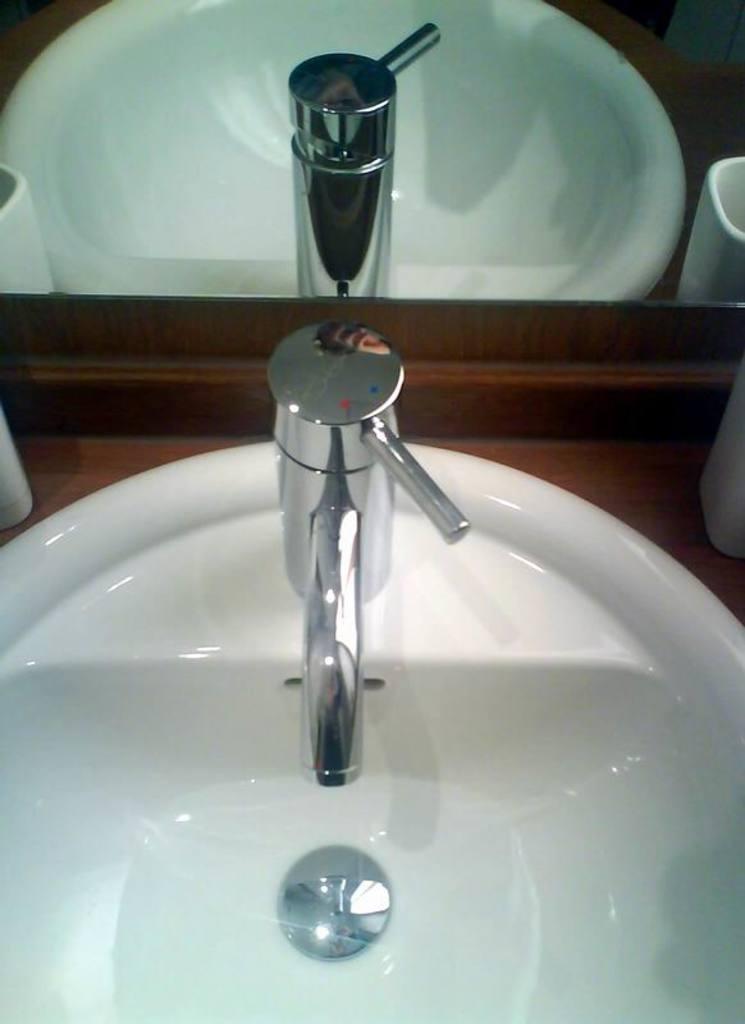Can you describe this image briefly? In the image in the center, we can see one sink, tap, mug, etc.. In the background there is a mirror, in which we can see the reflection of the sink, tap, mug and tissue paper. 